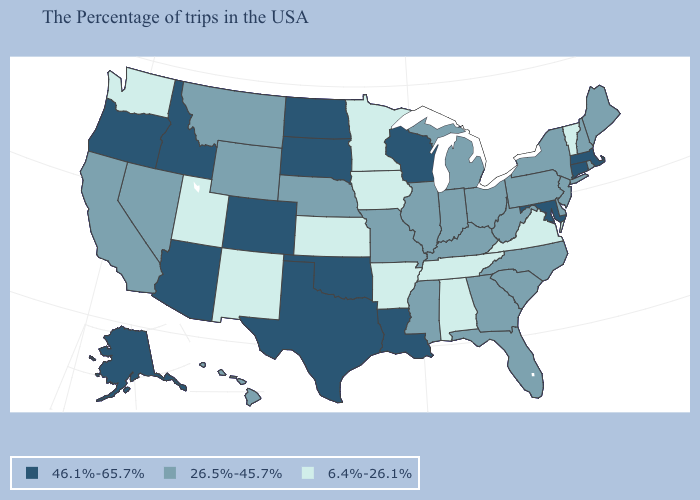Does Kansas have the lowest value in the MidWest?
Keep it brief. Yes. Does Washington have the lowest value in the West?
Keep it brief. Yes. Among the states that border Oregon , which have the lowest value?
Give a very brief answer. Washington. What is the value of New York?
Quick response, please. 26.5%-45.7%. Among the states that border Pennsylvania , does Delaware have the highest value?
Concise answer only. No. Name the states that have a value in the range 6.4%-26.1%?
Be succinct. Vermont, Virginia, Alabama, Tennessee, Arkansas, Minnesota, Iowa, Kansas, New Mexico, Utah, Washington. Does Hawaii have the lowest value in the West?
Give a very brief answer. No. Among the states that border Wyoming , which have the lowest value?
Write a very short answer. Utah. Does South Carolina have the lowest value in the USA?
Short answer required. No. Which states have the highest value in the USA?
Give a very brief answer. Massachusetts, Connecticut, Maryland, Wisconsin, Louisiana, Oklahoma, Texas, South Dakota, North Dakota, Colorado, Arizona, Idaho, Oregon, Alaska. Does New Mexico have a lower value than Illinois?
Answer briefly. Yes. Name the states that have a value in the range 26.5%-45.7%?
Quick response, please. Maine, Rhode Island, New Hampshire, New York, New Jersey, Delaware, Pennsylvania, North Carolina, South Carolina, West Virginia, Ohio, Florida, Georgia, Michigan, Kentucky, Indiana, Illinois, Mississippi, Missouri, Nebraska, Wyoming, Montana, Nevada, California, Hawaii. Does Hawaii have the lowest value in the USA?
Keep it brief. No. Among the states that border Minnesota , which have the highest value?
Give a very brief answer. Wisconsin, South Dakota, North Dakota. Does the first symbol in the legend represent the smallest category?
Write a very short answer. No. 